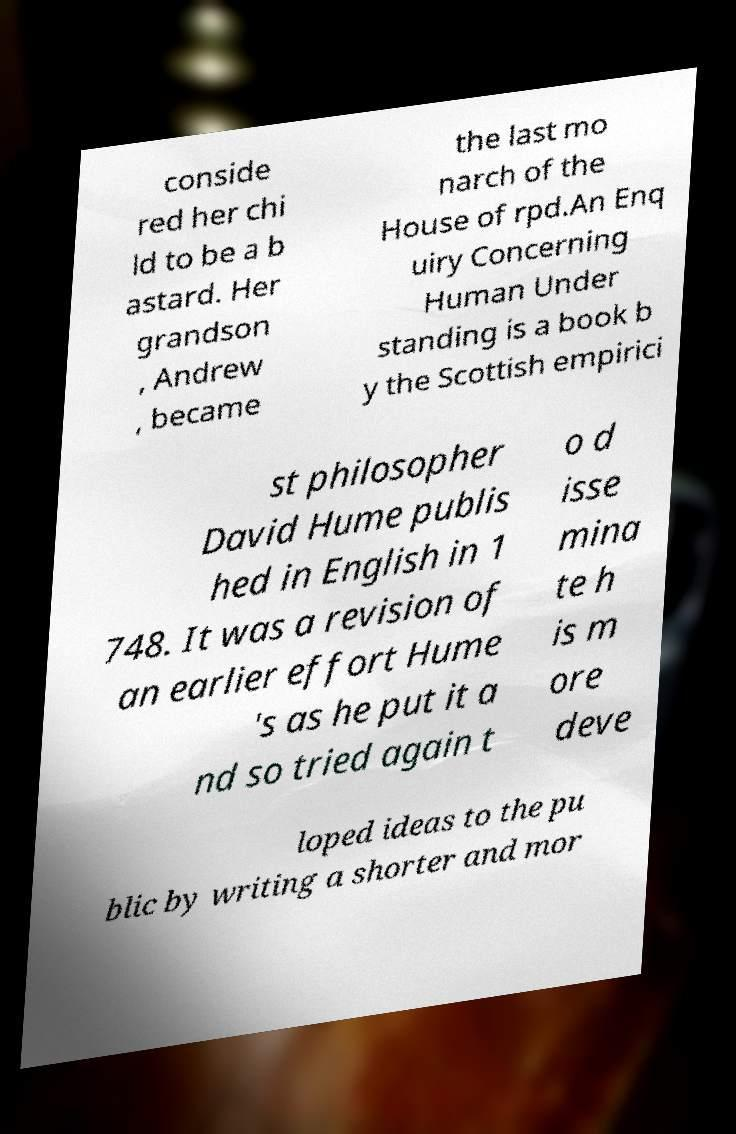There's text embedded in this image that I need extracted. Can you transcribe it verbatim? conside red her chi ld to be a b astard. Her grandson , Andrew , became the last mo narch of the House of rpd.An Enq uiry Concerning Human Under standing is a book b y the Scottish empirici st philosopher David Hume publis hed in English in 1 748. It was a revision of an earlier effort Hume 's as he put it a nd so tried again t o d isse mina te h is m ore deve loped ideas to the pu blic by writing a shorter and mor 